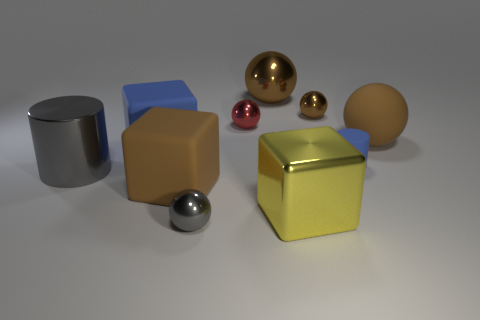Subtract all big metal blocks. How many blocks are left? 2 Subtract all blue cubes. How many cubes are left? 2 Subtract 2 spheres. How many spheres are left? 3 Subtract all cylinders. How many objects are left? 8 Subtract all yellow cylinders. How many cyan balls are left? 0 Subtract all large rubber objects. Subtract all red metallic balls. How many objects are left? 6 Add 5 large blue things. How many large blue things are left? 6 Add 4 tiny cylinders. How many tiny cylinders exist? 5 Subtract 1 blue cubes. How many objects are left? 9 Subtract all purple blocks. Subtract all green cylinders. How many blocks are left? 3 